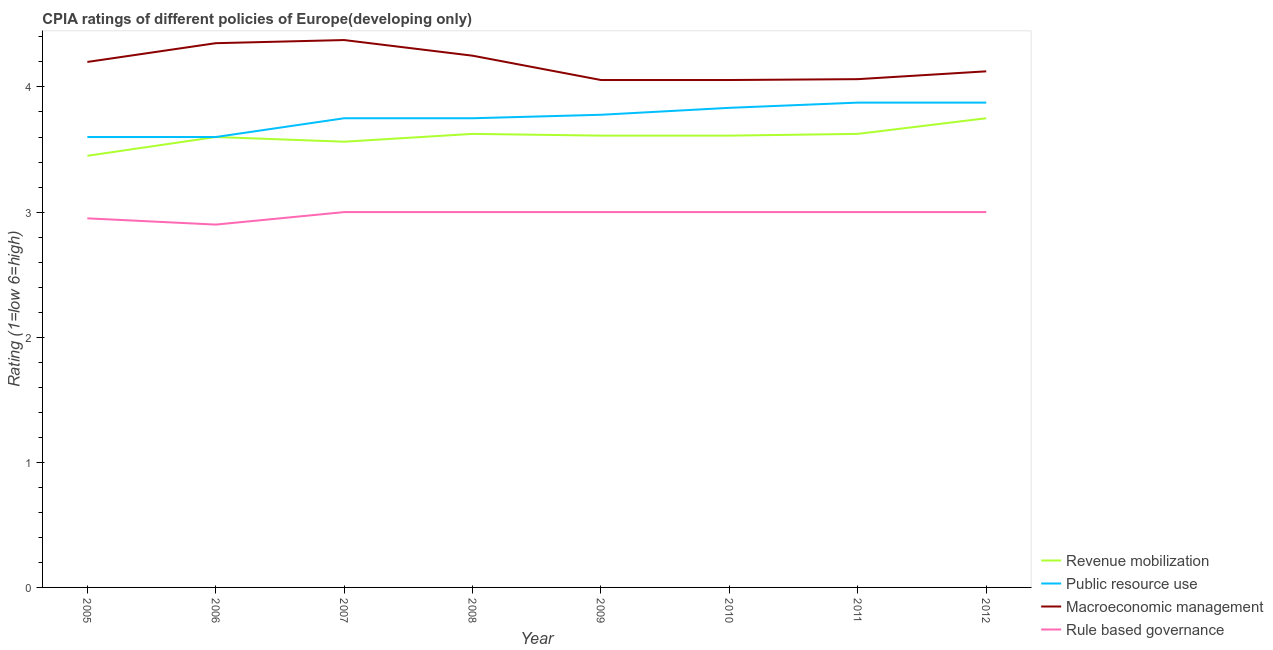Does the line corresponding to cpia rating of macroeconomic management intersect with the line corresponding to cpia rating of public resource use?
Provide a short and direct response. No. What is the cpia rating of revenue mobilization in 2011?
Keep it short and to the point. 3.62. Across all years, what is the maximum cpia rating of revenue mobilization?
Your response must be concise. 3.75. In which year was the cpia rating of rule based governance minimum?
Keep it short and to the point. 2006. What is the total cpia rating of macroeconomic management in the graph?
Keep it short and to the point. 33.47. What is the difference between the cpia rating of revenue mobilization in 2006 and that in 2008?
Your answer should be compact. -0.02. What is the difference between the cpia rating of rule based governance in 2009 and the cpia rating of revenue mobilization in 2007?
Your answer should be compact. -0.56. What is the average cpia rating of macroeconomic management per year?
Ensure brevity in your answer.  4.18. What is the ratio of the cpia rating of revenue mobilization in 2006 to that in 2009?
Make the answer very short. 1. Is the cpia rating of revenue mobilization in 2010 less than that in 2012?
Make the answer very short. Yes. What is the difference between the highest and the second highest cpia rating of rule based governance?
Your answer should be compact. 0. What is the difference between the highest and the lowest cpia rating of rule based governance?
Provide a succinct answer. 0.1. In how many years, is the cpia rating of rule based governance greater than the average cpia rating of rule based governance taken over all years?
Offer a terse response. 6. Is the sum of the cpia rating of rule based governance in 2009 and 2012 greater than the maximum cpia rating of public resource use across all years?
Give a very brief answer. Yes. Is it the case that in every year, the sum of the cpia rating of rule based governance and cpia rating of revenue mobilization is greater than the sum of cpia rating of macroeconomic management and cpia rating of public resource use?
Offer a terse response. No. Is it the case that in every year, the sum of the cpia rating of revenue mobilization and cpia rating of public resource use is greater than the cpia rating of macroeconomic management?
Make the answer very short. Yes. Is the cpia rating of public resource use strictly greater than the cpia rating of rule based governance over the years?
Provide a succinct answer. Yes. How many lines are there?
Make the answer very short. 4. What is the difference between two consecutive major ticks on the Y-axis?
Make the answer very short. 1. Are the values on the major ticks of Y-axis written in scientific E-notation?
Provide a succinct answer. No. Does the graph contain any zero values?
Your answer should be very brief. No. Does the graph contain grids?
Your answer should be very brief. No. Where does the legend appear in the graph?
Offer a very short reply. Bottom right. How are the legend labels stacked?
Keep it short and to the point. Vertical. What is the title of the graph?
Provide a short and direct response. CPIA ratings of different policies of Europe(developing only). Does "Methodology assessment" appear as one of the legend labels in the graph?
Your response must be concise. No. What is the label or title of the X-axis?
Provide a succinct answer. Year. What is the label or title of the Y-axis?
Provide a succinct answer. Rating (1=low 6=high). What is the Rating (1=low 6=high) in Revenue mobilization in 2005?
Provide a succinct answer. 3.45. What is the Rating (1=low 6=high) of Public resource use in 2005?
Provide a short and direct response. 3.6. What is the Rating (1=low 6=high) in Rule based governance in 2005?
Offer a terse response. 2.95. What is the Rating (1=low 6=high) in Revenue mobilization in 2006?
Your answer should be very brief. 3.6. What is the Rating (1=low 6=high) of Macroeconomic management in 2006?
Make the answer very short. 4.35. What is the Rating (1=low 6=high) in Revenue mobilization in 2007?
Your answer should be compact. 3.56. What is the Rating (1=low 6=high) in Public resource use in 2007?
Keep it short and to the point. 3.75. What is the Rating (1=low 6=high) of Macroeconomic management in 2007?
Give a very brief answer. 4.38. What is the Rating (1=low 6=high) in Revenue mobilization in 2008?
Make the answer very short. 3.62. What is the Rating (1=low 6=high) in Public resource use in 2008?
Give a very brief answer. 3.75. What is the Rating (1=low 6=high) in Macroeconomic management in 2008?
Your response must be concise. 4.25. What is the Rating (1=low 6=high) in Revenue mobilization in 2009?
Your response must be concise. 3.61. What is the Rating (1=low 6=high) of Public resource use in 2009?
Ensure brevity in your answer.  3.78. What is the Rating (1=low 6=high) of Macroeconomic management in 2009?
Keep it short and to the point. 4.06. What is the Rating (1=low 6=high) of Revenue mobilization in 2010?
Offer a terse response. 3.61. What is the Rating (1=low 6=high) in Public resource use in 2010?
Provide a succinct answer. 3.83. What is the Rating (1=low 6=high) in Macroeconomic management in 2010?
Your answer should be compact. 4.06. What is the Rating (1=low 6=high) of Rule based governance in 2010?
Ensure brevity in your answer.  3. What is the Rating (1=low 6=high) in Revenue mobilization in 2011?
Your answer should be compact. 3.62. What is the Rating (1=low 6=high) in Public resource use in 2011?
Give a very brief answer. 3.88. What is the Rating (1=low 6=high) of Macroeconomic management in 2011?
Ensure brevity in your answer.  4.06. What is the Rating (1=low 6=high) in Rule based governance in 2011?
Your response must be concise. 3. What is the Rating (1=low 6=high) in Revenue mobilization in 2012?
Your answer should be compact. 3.75. What is the Rating (1=low 6=high) in Public resource use in 2012?
Ensure brevity in your answer.  3.88. What is the Rating (1=low 6=high) of Macroeconomic management in 2012?
Provide a short and direct response. 4.12. What is the Rating (1=low 6=high) of Rule based governance in 2012?
Provide a succinct answer. 3. Across all years, what is the maximum Rating (1=low 6=high) of Revenue mobilization?
Offer a terse response. 3.75. Across all years, what is the maximum Rating (1=low 6=high) in Public resource use?
Offer a terse response. 3.88. Across all years, what is the maximum Rating (1=low 6=high) in Macroeconomic management?
Offer a very short reply. 4.38. Across all years, what is the minimum Rating (1=low 6=high) of Revenue mobilization?
Ensure brevity in your answer.  3.45. Across all years, what is the minimum Rating (1=low 6=high) in Macroeconomic management?
Your answer should be compact. 4.06. Across all years, what is the minimum Rating (1=low 6=high) in Rule based governance?
Your response must be concise. 2.9. What is the total Rating (1=low 6=high) in Revenue mobilization in the graph?
Provide a short and direct response. 28.83. What is the total Rating (1=low 6=high) in Public resource use in the graph?
Offer a very short reply. 30.06. What is the total Rating (1=low 6=high) in Macroeconomic management in the graph?
Your response must be concise. 33.47. What is the total Rating (1=low 6=high) in Rule based governance in the graph?
Provide a succinct answer. 23.85. What is the difference between the Rating (1=low 6=high) of Public resource use in 2005 and that in 2006?
Give a very brief answer. 0. What is the difference between the Rating (1=low 6=high) in Macroeconomic management in 2005 and that in 2006?
Offer a very short reply. -0.15. What is the difference between the Rating (1=low 6=high) in Rule based governance in 2005 and that in 2006?
Keep it short and to the point. 0.05. What is the difference between the Rating (1=low 6=high) in Revenue mobilization in 2005 and that in 2007?
Make the answer very short. -0.11. What is the difference between the Rating (1=low 6=high) in Macroeconomic management in 2005 and that in 2007?
Provide a succinct answer. -0.17. What is the difference between the Rating (1=low 6=high) in Revenue mobilization in 2005 and that in 2008?
Keep it short and to the point. -0.17. What is the difference between the Rating (1=low 6=high) of Rule based governance in 2005 and that in 2008?
Make the answer very short. -0.05. What is the difference between the Rating (1=low 6=high) of Revenue mobilization in 2005 and that in 2009?
Provide a succinct answer. -0.16. What is the difference between the Rating (1=low 6=high) in Public resource use in 2005 and that in 2009?
Your answer should be compact. -0.18. What is the difference between the Rating (1=low 6=high) of Macroeconomic management in 2005 and that in 2009?
Provide a succinct answer. 0.14. What is the difference between the Rating (1=low 6=high) in Rule based governance in 2005 and that in 2009?
Make the answer very short. -0.05. What is the difference between the Rating (1=low 6=high) of Revenue mobilization in 2005 and that in 2010?
Ensure brevity in your answer.  -0.16. What is the difference between the Rating (1=low 6=high) in Public resource use in 2005 and that in 2010?
Your response must be concise. -0.23. What is the difference between the Rating (1=low 6=high) in Macroeconomic management in 2005 and that in 2010?
Your answer should be very brief. 0.14. What is the difference between the Rating (1=low 6=high) in Rule based governance in 2005 and that in 2010?
Provide a succinct answer. -0.05. What is the difference between the Rating (1=low 6=high) in Revenue mobilization in 2005 and that in 2011?
Provide a succinct answer. -0.17. What is the difference between the Rating (1=low 6=high) of Public resource use in 2005 and that in 2011?
Your answer should be compact. -0.28. What is the difference between the Rating (1=low 6=high) of Macroeconomic management in 2005 and that in 2011?
Provide a succinct answer. 0.14. What is the difference between the Rating (1=low 6=high) in Public resource use in 2005 and that in 2012?
Provide a succinct answer. -0.28. What is the difference between the Rating (1=low 6=high) of Macroeconomic management in 2005 and that in 2012?
Give a very brief answer. 0.07. What is the difference between the Rating (1=low 6=high) of Rule based governance in 2005 and that in 2012?
Keep it short and to the point. -0.05. What is the difference between the Rating (1=low 6=high) in Revenue mobilization in 2006 and that in 2007?
Provide a succinct answer. 0.04. What is the difference between the Rating (1=low 6=high) in Public resource use in 2006 and that in 2007?
Your answer should be very brief. -0.15. What is the difference between the Rating (1=low 6=high) in Macroeconomic management in 2006 and that in 2007?
Ensure brevity in your answer.  -0.03. What is the difference between the Rating (1=low 6=high) in Rule based governance in 2006 and that in 2007?
Make the answer very short. -0.1. What is the difference between the Rating (1=low 6=high) of Revenue mobilization in 2006 and that in 2008?
Provide a succinct answer. -0.03. What is the difference between the Rating (1=low 6=high) of Macroeconomic management in 2006 and that in 2008?
Your answer should be very brief. 0.1. What is the difference between the Rating (1=low 6=high) in Rule based governance in 2006 and that in 2008?
Offer a terse response. -0.1. What is the difference between the Rating (1=low 6=high) in Revenue mobilization in 2006 and that in 2009?
Offer a very short reply. -0.01. What is the difference between the Rating (1=low 6=high) of Public resource use in 2006 and that in 2009?
Offer a very short reply. -0.18. What is the difference between the Rating (1=low 6=high) of Macroeconomic management in 2006 and that in 2009?
Make the answer very short. 0.29. What is the difference between the Rating (1=low 6=high) in Rule based governance in 2006 and that in 2009?
Provide a succinct answer. -0.1. What is the difference between the Rating (1=low 6=high) in Revenue mobilization in 2006 and that in 2010?
Provide a short and direct response. -0.01. What is the difference between the Rating (1=low 6=high) of Public resource use in 2006 and that in 2010?
Offer a very short reply. -0.23. What is the difference between the Rating (1=low 6=high) of Macroeconomic management in 2006 and that in 2010?
Offer a very short reply. 0.29. What is the difference between the Rating (1=low 6=high) of Rule based governance in 2006 and that in 2010?
Your answer should be compact. -0.1. What is the difference between the Rating (1=low 6=high) of Revenue mobilization in 2006 and that in 2011?
Offer a very short reply. -0.03. What is the difference between the Rating (1=low 6=high) of Public resource use in 2006 and that in 2011?
Offer a terse response. -0.28. What is the difference between the Rating (1=low 6=high) in Macroeconomic management in 2006 and that in 2011?
Provide a short and direct response. 0.29. What is the difference between the Rating (1=low 6=high) in Revenue mobilization in 2006 and that in 2012?
Provide a succinct answer. -0.15. What is the difference between the Rating (1=low 6=high) in Public resource use in 2006 and that in 2012?
Give a very brief answer. -0.28. What is the difference between the Rating (1=low 6=high) of Macroeconomic management in 2006 and that in 2012?
Ensure brevity in your answer.  0.23. What is the difference between the Rating (1=low 6=high) of Revenue mobilization in 2007 and that in 2008?
Keep it short and to the point. -0.06. What is the difference between the Rating (1=low 6=high) of Rule based governance in 2007 and that in 2008?
Offer a very short reply. 0. What is the difference between the Rating (1=low 6=high) in Revenue mobilization in 2007 and that in 2009?
Make the answer very short. -0.05. What is the difference between the Rating (1=low 6=high) of Public resource use in 2007 and that in 2009?
Keep it short and to the point. -0.03. What is the difference between the Rating (1=low 6=high) in Macroeconomic management in 2007 and that in 2009?
Make the answer very short. 0.32. What is the difference between the Rating (1=low 6=high) of Rule based governance in 2007 and that in 2009?
Provide a short and direct response. 0. What is the difference between the Rating (1=low 6=high) of Revenue mobilization in 2007 and that in 2010?
Your answer should be compact. -0.05. What is the difference between the Rating (1=low 6=high) of Public resource use in 2007 and that in 2010?
Your response must be concise. -0.08. What is the difference between the Rating (1=low 6=high) in Macroeconomic management in 2007 and that in 2010?
Your answer should be compact. 0.32. What is the difference between the Rating (1=low 6=high) of Rule based governance in 2007 and that in 2010?
Ensure brevity in your answer.  0. What is the difference between the Rating (1=low 6=high) in Revenue mobilization in 2007 and that in 2011?
Provide a succinct answer. -0.06. What is the difference between the Rating (1=low 6=high) in Public resource use in 2007 and that in 2011?
Your response must be concise. -0.12. What is the difference between the Rating (1=low 6=high) of Macroeconomic management in 2007 and that in 2011?
Your response must be concise. 0.31. What is the difference between the Rating (1=low 6=high) in Rule based governance in 2007 and that in 2011?
Offer a very short reply. 0. What is the difference between the Rating (1=low 6=high) of Revenue mobilization in 2007 and that in 2012?
Provide a succinct answer. -0.19. What is the difference between the Rating (1=low 6=high) of Public resource use in 2007 and that in 2012?
Provide a succinct answer. -0.12. What is the difference between the Rating (1=low 6=high) in Rule based governance in 2007 and that in 2012?
Offer a terse response. 0. What is the difference between the Rating (1=low 6=high) in Revenue mobilization in 2008 and that in 2009?
Offer a very short reply. 0.01. What is the difference between the Rating (1=low 6=high) in Public resource use in 2008 and that in 2009?
Your answer should be very brief. -0.03. What is the difference between the Rating (1=low 6=high) of Macroeconomic management in 2008 and that in 2009?
Offer a terse response. 0.19. What is the difference between the Rating (1=low 6=high) of Revenue mobilization in 2008 and that in 2010?
Your answer should be compact. 0.01. What is the difference between the Rating (1=low 6=high) of Public resource use in 2008 and that in 2010?
Your response must be concise. -0.08. What is the difference between the Rating (1=low 6=high) of Macroeconomic management in 2008 and that in 2010?
Ensure brevity in your answer.  0.19. What is the difference between the Rating (1=low 6=high) in Public resource use in 2008 and that in 2011?
Offer a terse response. -0.12. What is the difference between the Rating (1=low 6=high) of Macroeconomic management in 2008 and that in 2011?
Give a very brief answer. 0.19. What is the difference between the Rating (1=low 6=high) in Rule based governance in 2008 and that in 2011?
Offer a very short reply. 0. What is the difference between the Rating (1=low 6=high) of Revenue mobilization in 2008 and that in 2012?
Give a very brief answer. -0.12. What is the difference between the Rating (1=low 6=high) of Public resource use in 2008 and that in 2012?
Offer a terse response. -0.12. What is the difference between the Rating (1=low 6=high) of Rule based governance in 2008 and that in 2012?
Provide a short and direct response. 0. What is the difference between the Rating (1=low 6=high) of Public resource use in 2009 and that in 2010?
Keep it short and to the point. -0.06. What is the difference between the Rating (1=low 6=high) in Rule based governance in 2009 and that in 2010?
Your response must be concise. 0. What is the difference between the Rating (1=low 6=high) of Revenue mobilization in 2009 and that in 2011?
Keep it short and to the point. -0.01. What is the difference between the Rating (1=low 6=high) in Public resource use in 2009 and that in 2011?
Ensure brevity in your answer.  -0.1. What is the difference between the Rating (1=low 6=high) of Macroeconomic management in 2009 and that in 2011?
Make the answer very short. -0.01. What is the difference between the Rating (1=low 6=high) of Rule based governance in 2009 and that in 2011?
Make the answer very short. 0. What is the difference between the Rating (1=low 6=high) of Revenue mobilization in 2009 and that in 2012?
Your response must be concise. -0.14. What is the difference between the Rating (1=low 6=high) of Public resource use in 2009 and that in 2012?
Your answer should be compact. -0.1. What is the difference between the Rating (1=low 6=high) in Macroeconomic management in 2009 and that in 2012?
Your response must be concise. -0.07. What is the difference between the Rating (1=low 6=high) in Revenue mobilization in 2010 and that in 2011?
Your answer should be compact. -0.01. What is the difference between the Rating (1=low 6=high) of Public resource use in 2010 and that in 2011?
Ensure brevity in your answer.  -0.04. What is the difference between the Rating (1=low 6=high) in Macroeconomic management in 2010 and that in 2011?
Offer a terse response. -0.01. What is the difference between the Rating (1=low 6=high) of Rule based governance in 2010 and that in 2011?
Give a very brief answer. 0. What is the difference between the Rating (1=low 6=high) of Revenue mobilization in 2010 and that in 2012?
Keep it short and to the point. -0.14. What is the difference between the Rating (1=low 6=high) of Public resource use in 2010 and that in 2012?
Give a very brief answer. -0.04. What is the difference between the Rating (1=low 6=high) of Macroeconomic management in 2010 and that in 2012?
Your response must be concise. -0.07. What is the difference between the Rating (1=low 6=high) in Rule based governance in 2010 and that in 2012?
Give a very brief answer. 0. What is the difference between the Rating (1=low 6=high) of Revenue mobilization in 2011 and that in 2012?
Provide a succinct answer. -0.12. What is the difference between the Rating (1=low 6=high) of Public resource use in 2011 and that in 2012?
Your answer should be very brief. 0. What is the difference between the Rating (1=low 6=high) in Macroeconomic management in 2011 and that in 2012?
Make the answer very short. -0.06. What is the difference between the Rating (1=low 6=high) in Revenue mobilization in 2005 and the Rating (1=low 6=high) in Public resource use in 2006?
Make the answer very short. -0.15. What is the difference between the Rating (1=low 6=high) of Revenue mobilization in 2005 and the Rating (1=low 6=high) of Macroeconomic management in 2006?
Offer a very short reply. -0.9. What is the difference between the Rating (1=low 6=high) of Revenue mobilization in 2005 and the Rating (1=low 6=high) of Rule based governance in 2006?
Offer a very short reply. 0.55. What is the difference between the Rating (1=low 6=high) in Public resource use in 2005 and the Rating (1=low 6=high) in Macroeconomic management in 2006?
Your answer should be compact. -0.75. What is the difference between the Rating (1=low 6=high) of Revenue mobilization in 2005 and the Rating (1=low 6=high) of Public resource use in 2007?
Provide a short and direct response. -0.3. What is the difference between the Rating (1=low 6=high) in Revenue mobilization in 2005 and the Rating (1=low 6=high) in Macroeconomic management in 2007?
Give a very brief answer. -0.93. What is the difference between the Rating (1=low 6=high) of Revenue mobilization in 2005 and the Rating (1=low 6=high) of Rule based governance in 2007?
Ensure brevity in your answer.  0.45. What is the difference between the Rating (1=low 6=high) of Public resource use in 2005 and the Rating (1=low 6=high) of Macroeconomic management in 2007?
Provide a short and direct response. -0.78. What is the difference between the Rating (1=low 6=high) in Public resource use in 2005 and the Rating (1=low 6=high) in Rule based governance in 2007?
Provide a succinct answer. 0.6. What is the difference between the Rating (1=low 6=high) of Revenue mobilization in 2005 and the Rating (1=low 6=high) of Rule based governance in 2008?
Provide a succinct answer. 0.45. What is the difference between the Rating (1=low 6=high) in Public resource use in 2005 and the Rating (1=low 6=high) in Macroeconomic management in 2008?
Offer a very short reply. -0.65. What is the difference between the Rating (1=low 6=high) of Public resource use in 2005 and the Rating (1=low 6=high) of Rule based governance in 2008?
Offer a terse response. 0.6. What is the difference between the Rating (1=low 6=high) of Macroeconomic management in 2005 and the Rating (1=low 6=high) of Rule based governance in 2008?
Make the answer very short. 1.2. What is the difference between the Rating (1=low 6=high) of Revenue mobilization in 2005 and the Rating (1=low 6=high) of Public resource use in 2009?
Your answer should be very brief. -0.33. What is the difference between the Rating (1=low 6=high) in Revenue mobilization in 2005 and the Rating (1=low 6=high) in Macroeconomic management in 2009?
Ensure brevity in your answer.  -0.61. What is the difference between the Rating (1=low 6=high) of Revenue mobilization in 2005 and the Rating (1=low 6=high) of Rule based governance in 2009?
Provide a succinct answer. 0.45. What is the difference between the Rating (1=low 6=high) in Public resource use in 2005 and the Rating (1=low 6=high) in Macroeconomic management in 2009?
Your answer should be compact. -0.46. What is the difference between the Rating (1=low 6=high) in Public resource use in 2005 and the Rating (1=low 6=high) in Rule based governance in 2009?
Your answer should be compact. 0.6. What is the difference between the Rating (1=low 6=high) of Macroeconomic management in 2005 and the Rating (1=low 6=high) of Rule based governance in 2009?
Your response must be concise. 1.2. What is the difference between the Rating (1=low 6=high) in Revenue mobilization in 2005 and the Rating (1=low 6=high) in Public resource use in 2010?
Your answer should be compact. -0.38. What is the difference between the Rating (1=low 6=high) in Revenue mobilization in 2005 and the Rating (1=low 6=high) in Macroeconomic management in 2010?
Provide a succinct answer. -0.61. What is the difference between the Rating (1=low 6=high) in Revenue mobilization in 2005 and the Rating (1=low 6=high) in Rule based governance in 2010?
Provide a short and direct response. 0.45. What is the difference between the Rating (1=low 6=high) in Public resource use in 2005 and the Rating (1=low 6=high) in Macroeconomic management in 2010?
Offer a terse response. -0.46. What is the difference between the Rating (1=low 6=high) in Public resource use in 2005 and the Rating (1=low 6=high) in Rule based governance in 2010?
Give a very brief answer. 0.6. What is the difference between the Rating (1=low 6=high) in Revenue mobilization in 2005 and the Rating (1=low 6=high) in Public resource use in 2011?
Your answer should be compact. -0.42. What is the difference between the Rating (1=low 6=high) in Revenue mobilization in 2005 and the Rating (1=low 6=high) in Macroeconomic management in 2011?
Give a very brief answer. -0.61. What is the difference between the Rating (1=low 6=high) in Revenue mobilization in 2005 and the Rating (1=low 6=high) in Rule based governance in 2011?
Your answer should be compact. 0.45. What is the difference between the Rating (1=low 6=high) of Public resource use in 2005 and the Rating (1=low 6=high) of Macroeconomic management in 2011?
Your answer should be very brief. -0.46. What is the difference between the Rating (1=low 6=high) of Public resource use in 2005 and the Rating (1=low 6=high) of Rule based governance in 2011?
Keep it short and to the point. 0.6. What is the difference between the Rating (1=low 6=high) in Macroeconomic management in 2005 and the Rating (1=low 6=high) in Rule based governance in 2011?
Offer a very short reply. 1.2. What is the difference between the Rating (1=low 6=high) in Revenue mobilization in 2005 and the Rating (1=low 6=high) in Public resource use in 2012?
Provide a short and direct response. -0.42. What is the difference between the Rating (1=low 6=high) of Revenue mobilization in 2005 and the Rating (1=low 6=high) of Macroeconomic management in 2012?
Ensure brevity in your answer.  -0.68. What is the difference between the Rating (1=low 6=high) in Revenue mobilization in 2005 and the Rating (1=low 6=high) in Rule based governance in 2012?
Offer a terse response. 0.45. What is the difference between the Rating (1=low 6=high) in Public resource use in 2005 and the Rating (1=low 6=high) in Macroeconomic management in 2012?
Your response must be concise. -0.53. What is the difference between the Rating (1=low 6=high) of Macroeconomic management in 2005 and the Rating (1=low 6=high) of Rule based governance in 2012?
Ensure brevity in your answer.  1.2. What is the difference between the Rating (1=low 6=high) of Revenue mobilization in 2006 and the Rating (1=low 6=high) of Public resource use in 2007?
Keep it short and to the point. -0.15. What is the difference between the Rating (1=low 6=high) of Revenue mobilization in 2006 and the Rating (1=low 6=high) of Macroeconomic management in 2007?
Provide a succinct answer. -0.78. What is the difference between the Rating (1=low 6=high) in Revenue mobilization in 2006 and the Rating (1=low 6=high) in Rule based governance in 2007?
Give a very brief answer. 0.6. What is the difference between the Rating (1=low 6=high) in Public resource use in 2006 and the Rating (1=low 6=high) in Macroeconomic management in 2007?
Ensure brevity in your answer.  -0.78. What is the difference between the Rating (1=low 6=high) of Public resource use in 2006 and the Rating (1=low 6=high) of Rule based governance in 2007?
Provide a short and direct response. 0.6. What is the difference between the Rating (1=low 6=high) in Macroeconomic management in 2006 and the Rating (1=low 6=high) in Rule based governance in 2007?
Offer a terse response. 1.35. What is the difference between the Rating (1=low 6=high) of Revenue mobilization in 2006 and the Rating (1=low 6=high) of Public resource use in 2008?
Give a very brief answer. -0.15. What is the difference between the Rating (1=low 6=high) of Revenue mobilization in 2006 and the Rating (1=low 6=high) of Macroeconomic management in 2008?
Give a very brief answer. -0.65. What is the difference between the Rating (1=low 6=high) in Public resource use in 2006 and the Rating (1=low 6=high) in Macroeconomic management in 2008?
Offer a very short reply. -0.65. What is the difference between the Rating (1=low 6=high) of Public resource use in 2006 and the Rating (1=low 6=high) of Rule based governance in 2008?
Provide a succinct answer. 0.6. What is the difference between the Rating (1=low 6=high) in Macroeconomic management in 2006 and the Rating (1=low 6=high) in Rule based governance in 2008?
Your answer should be compact. 1.35. What is the difference between the Rating (1=low 6=high) of Revenue mobilization in 2006 and the Rating (1=low 6=high) of Public resource use in 2009?
Give a very brief answer. -0.18. What is the difference between the Rating (1=low 6=high) in Revenue mobilization in 2006 and the Rating (1=low 6=high) in Macroeconomic management in 2009?
Offer a terse response. -0.46. What is the difference between the Rating (1=low 6=high) of Revenue mobilization in 2006 and the Rating (1=low 6=high) of Rule based governance in 2009?
Offer a very short reply. 0.6. What is the difference between the Rating (1=low 6=high) in Public resource use in 2006 and the Rating (1=low 6=high) in Macroeconomic management in 2009?
Offer a terse response. -0.46. What is the difference between the Rating (1=low 6=high) in Public resource use in 2006 and the Rating (1=low 6=high) in Rule based governance in 2009?
Your answer should be compact. 0.6. What is the difference between the Rating (1=low 6=high) in Macroeconomic management in 2006 and the Rating (1=low 6=high) in Rule based governance in 2009?
Provide a succinct answer. 1.35. What is the difference between the Rating (1=low 6=high) in Revenue mobilization in 2006 and the Rating (1=low 6=high) in Public resource use in 2010?
Provide a succinct answer. -0.23. What is the difference between the Rating (1=low 6=high) in Revenue mobilization in 2006 and the Rating (1=low 6=high) in Macroeconomic management in 2010?
Your answer should be compact. -0.46. What is the difference between the Rating (1=low 6=high) in Public resource use in 2006 and the Rating (1=low 6=high) in Macroeconomic management in 2010?
Offer a terse response. -0.46. What is the difference between the Rating (1=low 6=high) in Macroeconomic management in 2006 and the Rating (1=low 6=high) in Rule based governance in 2010?
Offer a very short reply. 1.35. What is the difference between the Rating (1=low 6=high) in Revenue mobilization in 2006 and the Rating (1=low 6=high) in Public resource use in 2011?
Provide a short and direct response. -0.28. What is the difference between the Rating (1=low 6=high) of Revenue mobilization in 2006 and the Rating (1=low 6=high) of Macroeconomic management in 2011?
Offer a very short reply. -0.46. What is the difference between the Rating (1=low 6=high) of Public resource use in 2006 and the Rating (1=low 6=high) of Macroeconomic management in 2011?
Make the answer very short. -0.46. What is the difference between the Rating (1=low 6=high) of Macroeconomic management in 2006 and the Rating (1=low 6=high) of Rule based governance in 2011?
Offer a very short reply. 1.35. What is the difference between the Rating (1=low 6=high) in Revenue mobilization in 2006 and the Rating (1=low 6=high) in Public resource use in 2012?
Ensure brevity in your answer.  -0.28. What is the difference between the Rating (1=low 6=high) of Revenue mobilization in 2006 and the Rating (1=low 6=high) of Macroeconomic management in 2012?
Your answer should be compact. -0.53. What is the difference between the Rating (1=low 6=high) of Revenue mobilization in 2006 and the Rating (1=low 6=high) of Rule based governance in 2012?
Your response must be concise. 0.6. What is the difference between the Rating (1=low 6=high) in Public resource use in 2006 and the Rating (1=low 6=high) in Macroeconomic management in 2012?
Offer a very short reply. -0.53. What is the difference between the Rating (1=low 6=high) in Public resource use in 2006 and the Rating (1=low 6=high) in Rule based governance in 2012?
Make the answer very short. 0.6. What is the difference between the Rating (1=low 6=high) of Macroeconomic management in 2006 and the Rating (1=low 6=high) of Rule based governance in 2012?
Keep it short and to the point. 1.35. What is the difference between the Rating (1=low 6=high) of Revenue mobilization in 2007 and the Rating (1=low 6=high) of Public resource use in 2008?
Offer a very short reply. -0.19. What is the difference between the Rating (1=low 6=high) of Revenue mobilization in 2007 and the Rating (1=low 6=high) of Macroeconomic management in 2008?
Make the answer very short. -0.69. What is the difference between the Rating (1=low 6=high) in Revenue mobilization in 2007 and the Rating (1=low 6=high) in Rule based governance in 2008?
Make the answer very short. 0.56. What is the difference between the Rating (1=low 6=high) of Public resource use in 2007 and the Rating (1=low 6=high) of Macroeconomic management in 2008?
Your response must be concise. -0.5. What is the difference between the Rating (1=low 6=high) of Macroeconomic management in 2007 and the Rating (1=low 6=high) of Rule based governance in 2008?
Keep it short and to the point. 1.38. What is the difference between the Rating (1=low 6=high) in Revenue mobilization in 2007 and the Rating (1=low 6=high) in Public resource use in 2009?
Offer a very short reply. -0.22. What is the difference between the Rating (1=low 6=high) in Revenue mobilization in 2007 and the Rating (1=low 6=high) in Macroeconomic management in 2009?
Your answer should be compact. -0.49. What is the difference between the Rating (1=low 6=high) of Revenue mobilization in 2007 and the Rating (1=low 6=high) of Rule based governance in 2009?
Offer a very short reply. 0.56. What is the difference between the Rating (1=low 6=high) of Public resource use in 2007 and the Rating (1=low 6=high) of Macroeconomic management in 2009?
Your answer should be compact. -0.31. What is the difference between the Rating (1=low 6=high) of Public resource use in 2007 and the Rating (1=low 6=high) of Rule based governance in 2009?
Make the answer very short. 0.75. What is the difference between the Rating (1=low 6=high) in Macroeconomic management in 2007 and the Rating (1=low 6=high) in Rule based governance in 2009?
Your response must be concise. 1.38. What is the difference between the Rating (1=low 6=high) in Revenue mobilization in 2007 and the Rating (1=low 6=high) in Public resource use in 2010?
Make the answer very short. -0.27. What is the difference between the Rating (1=low 6=high) in Revenue mobilization in 2007 and the Rating (1=low 6=high) in Macroeconomic management in 2010?
Keep it short and to the point. -0.49. What is the difference between the Rating (1=low 6=high) in Revenue mobilization in 2007 and the Rating (1=low 6=high) in Rule based governance in 2010?
Provide a short and direct response. 0.56. What is the difference between the Rating (1=low 6=high) of Public resource use in 2007 and the Rating (1=low 6=high) of Macroeconomic management in 2010?
Ensure brevity in your answer.  -0.31. What is the difference between the Rating (1=low 6=high) in Public resource use in 2007 and the Rating (1=low 6=high) in Rule based governance in 2010?
Your answer should be compact. 0.75. What is the difference between the Rating (1=low 6=high) of Macroeconomic management in 2007 and the Rating (1=low 6=high) of Rule based governance in 2010?
Your answer should be very brief. 1.38. What is the difference between the Rating (1=low 6=high) of Revenue mobilization in 2007 and the Rating (1=low 6=high) of Public resource use in 2011?
Ensure brevity in your answer.  -0.31. What is the difference between the Rating (1=low 6=high) of Revenue mobilization in 2007 and the Rating (1=low 6=high) of Rule based governance in 2011?
Ensure brevity in your answer.  0.56. What is the difference between the Rating (1=low 6=high) of Public resource use in 2007 and the Rating (1=low 6=high) of Macroeconomic management in 2011?
Keep it short and to the point. -0.31. What is the difference between the Rating (1=low 6=high) in Macroeconomic management in 2007 and the Rating (1=low 6=high) in Rule based governance in 2011?
Offer a very short reply. 1.38. What is the difference between the Rating (1=low 6=high) in Revenue mobilization in 2007 and the Rating (1=low 6=high) in Public resource use in 2012?
Offer a very short reply. -0.31. What is the difference between the Rating (1=low 6=high) of Revenue mobilization in 2007 and the Rating (1=low 6=high) of Macroeconomic management in 2012?
Keep it short and to the point. -0.56. What is the difference between the Rating (1=low 6=high) of Revenue mobilization in 2007 and the Rating (1=low 6=high) of Rule based governance in 2012?
Provide a short and direct response. 0.56. What is the difference between the Rating (1=low 6=high) in Public resource use in 2007 and the Rating (1=low 6=high) in Macroeconomic management in 2012?
Keep it short and to the point. -0.38. What is the difference between the Rating (1=low 6=high) in Public resource use in 2007 and the Rating (1=low 6=high) in Rule based governance in 2012?
Provide a succinct answer. 0.75. What is the difference between the Rating (1=low 6=high) in Macroeconomic management in 2007 and the Rating (1=low 6=high) in Rule based governance in 2012?
Your response must be concise. 1.38. What is the difference between the Rating (1=low 6=high) in Revenue mobilization in 2008 and the Rating (1=low 6=high) in Public resource use in 2009?
Your response must be concise. -0.15. What is the difference between the Rating (1=low 6=high) of Revenue mobilization in 2008 and the Rating (1=low 6=high) of Macroeconomic management in 2009?
Offer a very short reply. -0.43. What is the difference between the Rating (1=low 6=high) of Revenue mobilization in 2008 and the Rating (1=low 6=high) of Rule based governance in 2009?
Your answer should be compact. 0.62. What is the difference between the Rating (1=low 6=high) of Public resource use in 2008 and the Rating (1=low 6=high) of Macroeconomic management in 2009?
Ensure brevity in your answer.  -0.31. What is the difference between the Rating (1=low 6=high) in Macroeconomic management in 2008 and the Rating (1=low 6=high) in Rule based governance in 2009?
Offer a terse response. 1.25. What is the difference between the Rating (1=low 6=high) of Revenue mobilization in 2008 and the Rating (1=low 6=high) of Public resource use in 2010?
Your answer should be compact. -0.21. What is the difference between the Rating (1=low 6=high) in Revenue mobilization in 2008 and the Rating (1=low 6=high) in Macroeconomic management in 2010?
Give a very brief answer. -0.43. What is the difference between the Rating (1=low 6=high) of Public resource use in 2008 and the Rating (1=low 6=high) of Macroeconomic management in 2010?
Your response must be concise. -0.31. What is the difference between the Rating (1=low 6=high) of Public resource use in 2008 and the Rating (1=low 6=high) of Rule based governance in 2010?
Provide a succinct answer. 0.75. What is the difference between the Rating (1=low 6=high) of Revenue mobilization in 2008 and the Rating (1=low 6=high) of Macroeconomic management in 2011?
Provide a short and direct response. -0.44. What is the difference between the Rating (1=low 6=high) in Public resource use in 2008 and the Rating (1=low 6=high) in Macroeconomic management in 2011?
Ensure brevity in your answer.  -0.31. What is the difference between the Rating (1=low 6=high) of Public resource use in 2008 and the Rating (1=low 6=high) of Rule based governance in 2011?
Provide a short and direct response. 0.75. What is the difference between the Rating (1=low 6=high) of Revenue mobilization in 2008 and the Rating (1=low 6=high) of Public resource use in 2012?
Ensure brevity in your answer.  -0.25. What is the difference between the Rating (1=low 6=high) in Public resource use in 2008 and the Rating (1=low 6=high) in Macroeconomic management in 2012?
Ensure brevity in your answer.  -0.38. What is the difference between the Rating (1=low 6=high) in Revenue mobilization in 2009 and the Rating (1=low 6=high) in Public resource use in 2010?
Ensure brevity in your answer.  -0.22. What is the difference between the Rating (1=low 6=high) of Revenue mobilization in 2009 and the Rating (1=low 6=high) of Macroeconomic management in 2010?
Offer a very short reply. -0.44. What is the difference between the Rating (1=low 6=high) in Revenue mobilization in 2009 and the Rating (1=low 6=high) in Rule based governance in 2010?
Provide a short and direct response. 0.61. What is the difference between the Rating (1=low 6=high) of Public resource use in 2009 and the Rating (1=low 6=high) of Macroeconomic management in 2010?
Make the answer very short. -0.28. What is the difference between the Rating (1=low 6=high) in Public resource use in 2009 and the Rating (1=low 6=high) in Rule based governance in 2010?
Provide a short and direct response. 0.78. What is the difference between the Rating (1=low 6=high) of Macroeconomic management in 2009 and the Rating (1=low 6=high) of Rule based governance in 2010?
Make the answer very short. 1.06. What is the difference between the Rating (1=low 6=high) of Revenue mobilization in 2009 and the Rating (1=low 6=high) of Public resource use in 2011?
Keep it short and to the point. -0.26. What is the difference between the Rating (1=low 6=high) in Revenue mobilization in 2009 and the Rating (1=low 6=high) in Macroeconomic management in 2011?
Your answer should be compact. -0.45. What is the difference between the Rating (1=low 6=high) of Revenue mobilization in 2009 and the Rating (1=low 6=high) of Rule based governance in 2011?
Your answer should be very brief. 0.61. What is the difference between the Rating (1=low 6=high) of Public resource use in 2009 and the Rating (1=low 6=high) of Macroeconomic management in 2011?
Provide a succinct answer. -0.28. What is the difference between the Rating (1=low 6=high) in Macroeconomic management in 2009 and the Rating (1=low 6=high) in Rule based governance in 2011?
Your answer should be compact. 1.06. What is the difference between the Rating (1=low 6=high) of Revenue mobilization in 2009 and the Rating (1=low 6=high) of Public resource use in 2012?
Give a very brief answer. -0.26. What is the difference between the Rating (1=low 6=high) in Revenue mobilization in 2009 and the Rating (1=low 6=high) in Macroeconomic management in 2012?
Your answer should be very brief. -0.51. What is the difference between the Rating (1=low 6=high) of Revenue mobilization in 2009 and the Rating (1=low 6=high) of Rule based governance in 2012?
Give a very brief answer. 0.61. What is the difference between the Rating (1=low 6=high) of Public resource use in 2009 and the Rating (1=low 6=high) of Macroeconomic management in 2012?
Provide a succinct answer. -0.35. What is the difference between the Rating (1=low 6=high) in Macroeconomic management in 2009 and the Rating (1=low 6=high) in Rule based governance in 2012?
Offer a very short reply. 1.06. What is the difference between the Rating (1=low 6=high) of Revenue mobilization in 2010 and the Rating (1=low 6=high) of Public resource use in 2011?
Ensure brevity in your answer.  -0.26. What is the difference between the Rating (1=low 6=high) in Revenue mobilization in 2010 and the Rating (1=low 6=high) in Macroeconomic management in 2011?
Provide a short and direct response. -0.45. What is the difference between the Rating (1=low 6=high) of Revenue mobilization in 2010 and the Rating (1=low 6=high) of Rule based governance in 2011?
Your answer should be very brief. 0.61. What is the difference between the Rating (1=low 6=high) of Public resource use in 2010 and the Rating (1=low 6=high) of Macroeconomic management in 2011?
Your response must be concise. -0.23. What is the difference between the Rating (1=low 6=high) of Macroeconomic management in 2010 and the Rating (1=low 6=high) of Rule based governance in 2011?
Your answer should be compact. 1.06. What is the difference between the Rating (1=low 6=high) of Revenue mobilization in 2010 and the Rating (1=low 6=high) of Public resource use in 2012?
Provide a short and direct response. -0.26. What is the difference between the Rating (1=low 6=high) of Revenue mobilization in 2010 and the Rating (1=low 6=high) of Macroeconomic management in 2012?
Your answer should be compact. -0.51. What is the difference between the Rating (1=low 6=high) of Revenue mobilization in 2010 and the Rating (1=low 6=high) of Rule based governance in 2012?
Make the answer very short. 0.61. What is the difference between the Rating (1=low 6=high) in Public resource use in 2010 and the Rating (1=low 6=high) in Macroeconomic management in 2012?
Your response must be concise. -0.29. What is the difference between the Rating (1=low 6=high) in Public resource use in 2010 and the Rating (1=low 6=high) in Rule based governance in 2012?
Give a very brief answer. 0.83. What is the difference between the Rating (1=low 6=high) of Macroeconomic management in 2010 and the Rating (1=low 6=high) of Rule based governance in 2012?
Offer a terse response. 1.06. What is the difference between the Rating (1=low 6=high) in Revenue mobilization in 2011 and the Rating (1=low 6=high) in Public resource use in 2012?
Provide a succinct answer. -0.25. What is the difference between the Rating (1=low 6=high) of Revenue mobilization in 2011 and the Rating (1=low 6=high) of Rule based governance in 2012?
Make the answer very short. 0.62. What is the average Rating (1=low 6=high) in Revenue mobilization per year?
Provide a short and direct response. 3.6. What is the average Rating (1=low 6=high) of Public resource use per year?
Keep it short and to the point. 3.76. What is the average Rating (1=low 6=high) of Macroeconomic management per year?
Your answer should be very brief. 4.18. What is the average Rating (1=low 6=high) of Rule based governance per year?
Offer a terse response. 2.98. In the year 2005, what is the difference between the Rating (1=low 6=high) of Revenue mobilization and Rating (1=low 6=high) of Public resource use?
Provide a succinct answer. -0.15. In the year 2005, what is the difference between the Rating (1=low 6=high) in Revenue mobilization and Rating (1=low 6=high) in Macroeconomic management?
Keep it short and to the point. -0.75. In the year 2005, what is the difference between the Rating (1=low 6=high) in Public resource use and Rating (1=low 6=high) in Macroeconomic management?
Provide a succinct answer. -0.6. In the year 2005, what is the difference between the Rating (1=low 6=high) in Public resource use and Rating (1=low 6=high) in Rule based governance?
Keep it short and to the point. 0.65. In the year 2006, what is the difference between the Rating (1=low 6=high) of Revenue mobilization and Rating (1=low 6=high) of Macroeconomic management?
Offer a very short reply. -0.75. In the year 2006, what is the difference between the Rating (1=low 6=high) in Revenue mobilization and Rating (1=low 6=high) in Rule based governance?
Give a very brief answer. 0.7. In the year 2006, what is the difference between the Rating (1=low 6=high) of Public resource use and Rating (1=low 6=high) of Macroeconomic management?
Offer a terse response. -0.75. In the year 2006, what is the difference between the Rating (1=low 6=high) of Macroeconomic management and Rating (1=low 6=high) of Rule based governance?
Offer a very short reply. 1.45. In the year 2007, what is the difference between the Rating (1=low 6=high) in Revenue mobilization and Rating (1=low 6=high) in Public resource use?
Your response must be concise. -0.19. In the year 2007, what is the difference between the Rating (1=low 6=high) of Revenue mobilization and Rating (1=low 6=high) of Macroeconomic management?
Make the answer very short. -0.81. In the year 2007, what is the difference between the Rating (1=low 6=high) in Revenue mobilization and Rating (1=low 6=high) in Rule based governance?
Your response must be concise. 0.56. In the year 2007, what is the difference between the Rating (1=low 6=high) in Public resource use and Rating (1=low 6=high) in Macroeconomic management?
Offer a very short reply. -0.62. In the year 2007, what is the difference between the Rating (1=low 6=high) of Public resource use and Rating (1=low 6=high) of Rule based governance?
Keep it short and to the point. 0.75. In the year 2007, what is the difference between the Rating (1=low 6=high) in Macroeconomic management and Rating (1=low 6=high) in Rule based governance?
Offer a terse response. 1.38. In the year 2008, what is the difference between the Rating (1=low 6=high) of Revenue mobilization and Rating (1=low 6=high) of Public resource use?
Provide a short and direct response. -0.12. In the year 2008, what is the difference between the Rating (1=low 6=high) of Revenue mobilization and Rating (1=low 6=high) of Macroeconomic management?
Make the answer very short. -0.62. In the year 2008, what is the difference between the Rating (1=low 6=high) in Public resource use and Rating (1=low 6=high) in Rule based governance?
Offer a terse response. 0.75. In the year 2009, what is the difference between the Rating (1=low 6=high) in Revenue mobilization and Rating (1=low 6=high) in Public resource use?
Provide a succinct answer. -0.17. In the year 2009, what is the difference between the Rating (1=low 6=high) of Revenue mobilization and Rating (1=low 6=high) of Macroeconomic management?
Provide a succinct answer. -0.44. In the year 2009, what is the difference between the Rating (1=low 6=high) of Revenue mobilization and Rating (1=low 6=high) of Rule based governance?
Offer a terse response. 0.61. In the year 2009, what is the difference between the Rating (1=low 6=high) of Public resource use and Rating (1=low 6=high) of Macroeconomic management?
Provide a succinct answer. -0.28. In the year 2009, what is the difference between the Rating (1=low 6=high) in Macroeconomic management and Rating (1=low 6=high) in Rule based governance?
Keep it short and to the point. 1.06. In the year 2010, what is the difference between the Rating (1=low 6=high) of Revenue mobilization and Rating (1=low 6=high) of Public resource use?
Make the answer very short. -0.22. In the year 2010, what is the difference between the Rating (1=low 6=high) in Revenue mobilization and Rating (1=low 6=high) in Macroeconomic management?
Ensure brevity in your answer.  -0.44. In the year 2010, what is the difference between the Rating (1=low 6=high) of Revenue mobilization and Rating (1=low 6=high) of Rule based governance?
Keep it short and to the point. 0.61. In the year 2010, what is the difference between the Rating (1=low 6=high) of Public resource use and Rating (1=low 6=high) of Macroeconomic management?
Offer a very short reply. -0.22. In the year 2010, what is the difference between the Rating (1=low 6=high) in Public resource use and Rating (1=low 6=high) in Rule based governance?
Your answer should be compact. 0.83. In the year 2010, what is the difference between the Rating (1=low 6=high) of Macroeconomic management and Rating (1=low 6=high) of Rule based governance?
Keep it short and to the point. 1.06. In the year 2011, what is the difference between the Rating (1=low 6=high) in Revenue mobilization and Rating (1=low 6=high) in Macroeconomic management?
Make the answer very short. -0.44. In the year 2011, what is the difference between the Rating (1=low 6=high) of Public resource use and Rating (1=low 6=high) of Macroeconomic management?
Make the answer very short. -0.19. In the year 2012, what is the difference between the Rating (1=low 6=high) of Revenue mobilization and Rating (1=low 6=high) of Public resource use?
Your answer should be compact. -0.12. In the year 2012, what is the difference between the Rating (1=low 6=high) in Revenue mobilization and Rating (1=low 6=high) in Macroeconomic management?
Offer a terse response. -0.38. In the year 2012, what is the difference between the Rating (1=low 6=high) of Macroeconomic management and Rating (1=low 6=high) of Rule based governance?
Your answer should be compact. 1.12. What is the ratio of the Rating (1=low 6=high) of Macroeconomic management in 2005 to that in 2006?
Offer a terse response. 0.97. What is the ratio of the Rating (1=low 6=high) in Rule based governance in 2005 to that in 2006?
Your answer should be compact. 1.02. What is the ratio of the Rating (1=low 6=high) of Revenue mobilization in 2005 to that in 2007?
Ensure brevity in your answer.  0.97. What is the ratio of the Rating (1=low 6=high) in Public resource use in 2005 to that in 2007?
Your answer should be compact. 0.96. What is the ratio of the Rating (1=low 6=high) in Macroeconomic management in 2005 to that in 2007?
Keep it short and to the point. 0.96. What is the ratio of the Rating (1=low 6=high) in Rule based governance in 2005 to that in 2007?
Make the answer very short. 0.98. What is the ratio of the Rating (1=low 6=high) in Revenue mobilization in 2005 to that in 2008?
Give a very brief answer. 0.95. What is the ratio of the Rating (1=low 6=high) of Public resource use in 2005 to that in 2008?
Offer a terse response. 0.96. What is the ratio of the Rating (1=low 6=high) of Rule based governance in 2005 to that in 2008?
Keep it short and to the point. 0.98. What is the ratio of the Rating (1=low 6=high) in Revenue mobilization in 2005 to that in 2009?
Your answer should be compact. 0.96. What is the ratio of the Rating (1=low 6=high) in Public resource use in 2005 to that in 2009?
Your response must be concise. 0.95. What is the ratio of the Rating (1=low 6=high) of Macroeconomic management in 2005 to that in 2009?
Make the answer very short. 1.04. What is the ratio of the Rating (1=low 6=high) of Rule based governance in 2005 to that in 2009?
Give a very brief answer. 0.98. What is the ratio of the Rating (1=low 6=high) in Revenue mobilization in 2005 to that in 2010?
Provide a succinct answer. 0.96. What is the ratio of the Rating (1=low 6=high) in Public resource use in 2005 to that in 2010?
Give a very brief answer. 0.94. What is the ratio of the Rating (1=low 6=high) of Macroeconomic management in 2005 to that in 2010?
Offer a terse response. 1.04. What is the ratio of the Rating (1=low 6=high) of Rule based governance in 2005 to that in 2010?
Provide a succinct answer. 0.98. What is the ratio of the Rating (1=low 6=high) of Revenue mobilization in 2005 to that in 2011?
Provide a short and direct response. 0.95. What is the ratio of the Rating (1=low 6=high) of Public resource use in 2005 to that in 2011?
Give a very brief answer. 0.93. What is the ratio of the Rating (1=low 6=high) in Macroeconomic management in 2005 to that in 2011?
Ensure brevity in your answer.  1.03. What is the ratio of the Rating (1=low 6=high) in Rule based governance in 2005 to that in 2011?
Your answer should be very brief. 0.98. What is the ratio of the Rating (1=low 6=high) of Revenue mobilization in 2005 to that in 2012?
Provide a succinct answer. 0.92. What is the ratio of the Rating (1=low 6=high) of Public resource use in 2005 to that in 2012?
Your answer should be compact. 0.93. What is the ratio of the Rating (1=low 6=high) of Macroeconomic management in 2005 to that in 2012?
Keep it short and to the point. 1.02. What is the ratio of the Rating (1=low 6=high) of Rule based governance in 2005 to that in 2012?
Make the answer very short. 0.98. What is the ratio of the Rating (1=low 6=high) of Revenue mobilization in 2006 to that in 2007?
Make the answer very short. 1.01. What is the ratio of the Rating (1=low 6=high) in Macroeconomic management in 2006 to that in 2007?
Give a very brief answer. 0.99. What is the ratio of the Rating (1=low 6=high) of Rule based governance in 2006 to that in 2007?
Ensure brevity in your answer.  0.97. What is the ratio of the Rating (1=low 6=high) of Public resource use in 2006 to that in 2008?
Ensure brevity in your answer.  0.96. What is the ratio of the Rating (1=low 6=high) of Macroeconomic management in 2006 to that in 2008?
Your response must be concise. 1.02. What is the ratio of the Rating (1=low 6=high) of Rule based governance in 2006 to that in 2008?
Your answer should be very brief. 0.97. What is the ratio of the Rating (1=low 6=high) of Revenue mobilization in 2006 to that in 2009?
Give a very brief answer. 1. What is the ratio of the Rating (1=low 6=high) of Public resource use in 2006 to that in 2009?
Provide a short and direct response. 0.95. What is the ratio of the Rating (1=low 6=high) in Macroeconomic management in 2006 to that in 2009?
Your answer should be compact. 1.07. What is the ratio of the Rating (1=low 6=high) of Rule based governance in 2006 to that in 2009?
Provide a succinct answer. 0.97. What is the ratio of the Rating (1=low 6=high) in Public resource use in 2006 to that in 2010?
Provide a succinct answer. 0.94. What is the ratio of the Rating (1=low 6=high) of Macroeconomic management in 2006 to that in 2010?
Keep it short and to the point. 1.07. What is the ratio of the Rating (1=low 6=high) in Rule based governance in 2006 to that in 2010?
Offer a very short reply. 0.97. What is the ratio of the Rating (1=low 6=high) of Revenue mobilization in 2006 to that in 2011?
Offer a terse response. 0.99. What is the ratio of the Rating (1=low 6=high) in Public resource use in 2006 to that in 2011?
Your answer should be very brief. 0.93. What is the ratio of the Rating (1=low 6=high) of Macroeconomic management in 2006 to that in 2011?
Give a very brief answer. 1.07. What is the ratio of the Rating (1=low 6=high) in Rule based governance in 2006 to that in 2011?
Your response must be concise. 0.97. What is the ratio of the Rating (1=low 6=high) of Public resource use in 2006 to that in 2012?
Your answer should be compact. 0.93. What is the ratio of the Rating (1=low 6=high) in Macroeconomic management in 2006 to that in 2012?
Give a very brief answer. 1.05. What is the ratio of the Rating (1=low 6=high) of Rule based governance in 2006 to that in 2012?
Give a very brief answer. 0.97. What is the ratio of the Rating (1=low 6=high) in Revenue mobilization in 2007 to that in 2008?
Provide a succinct answer. 0.98. What is the ratio of the Rating (1=low 6=high) in Public resource use in 2007 to that in 2008?
Provide a short and direct response. 1. What is the ratio of the Rating (1=low 6=high) of Macroeconomic management in 2007 to that in 2008?
Your response must be concise. 1.03. What is the ratio of the Rating (1=low 6=high) in Rule based governance in 2007 to that in 2008?
Make the answer very short. 1. What is the ratio of the Rating (1=low 6=high) of Revenue mobilization in 2007 to that in 2009?
Ensure brevity in your answer.  0.99. What is the ratio of the Rating (1=low 6=high) in Public resource use in 2007 to that in 2009?
Offer a terse response. 0.99. What is the ratio of the Rating (1=low 6=high) of Macroeconomic management in 2007 to that in 2009?
Offer a terse response. 1.08. What is the ratio of the Rating (1=low 6=high) in Revenue mobilization in 2007 to that in 2010?
Offer a terse response. 0.99. What is the ratio of the Rating (1=low 6=high) in Public resource use in 2007 to that in 2010?
Make the answer very short. 0.98. What is the ratio of the Rating (1=low 6=high) in Macroeconomic management in 2007 to that in 2010?
Provide a succinct answer. 1.08. What is the ratio of the Rating (1=low 6=high) in Rule based governance in 2007 to that in 2010?
Your answer should be very brief. 1. What is the ratio of the Rating (1=low 6=high) of Revenue mobilization in 2007 to that in 2011?
Offer a terse response. 0.98. What is the ratio of the Rating (1=low 6=high) in Macroeconomic management in 2007 to that in 2011?
Give a very brief answer. 1.08. What is the ratio of the Rating (1=low 6=high) in Rule based governance in 2007 to that in 2011?
Provide a succinct answer. 1. What is the ratio of the Rating (1=low 6=high) of Revenue mobilization in 2007 to that in 2012?
Make the answer very short. 0.95. What is the ratio of the Rating (1=low 6=high) in Macroeconomic management in 2007 to that in 2012?
Keep it short and to the point. 1.06. What is the ratio of the Rating (1=low 6=high) of Macroeconomic management in 2008 to that in 2009?
Ensure brevity in your answer.  1.05. What is the ratio of the Rating (1=low 6=high) of Revenue mobilization in 2008 to that in 2010?
Your answer should be very brief. 1. What is the ratio of the Rating (1=low 6=high) in Public resource use in 2008 to that in 2010?
Your answer should be compact. 0.98. What is the ratio of the Rating (1=low 6=high) of Macroeconomic management in 2008 to that in 2010?
Your answer should be compact. 1.05. What is the ratio of the Rating (1=low 6=high) in Public resource use in 2008 to that in 2011?
Give a very brief answer. 0.97. What is the ratio of the Rating (1=low 6=high) in Macroeconomic management in 2008 to that in 2011?
Your response must be concise. 1.05. What is the ratio of the Rating (1=low 6=high) in Rule based governance in 2008 to that in 2011?
Provide a succinct answer. 1. What is the ratio of the Rating (1=low 6=high) in Revenue mobilization in 2008 to that in 2012?
Make the answer very short. 0.97. What is the ratio of the Rating (1=low 6=high) of Public resource use in 2008 to that in 2012?
Keep it short and to the point. 0.97. What is the ratio of the Rating (1=low 6=high) in Macroeconomic management in 2008 to that in 2012?
Make the answer very short. 1.03. What is the ratio of the Rating (1=low 6=high) in Public resource use in 2009 to that in 2010?
Provide a succinct answer. 0.99. What is the ratio of the Rating (1=low 6=high) in Revenue mobilization in 2009 to that in 2011?
Give a very brief answer. 1. What is the ratio of the Rating (1=low 6=high) in Public resource use in 2009 to that in 2011?
Offer a very short reply. 0.97. What is the ratio of the Rating (1=low 6=high) in Macroeconomic management in 2009 to that in 2011?
Provide a short and direct response. 1. What is the ratio of the Rating (1=low 6=high) of Rule based governance in 2009 to that in 2011?
Your response must be concise. 1. What is the ratio of the Rating (1=low 6=high) of Public resource use in 2009 to that in 2012?
Your answer should be very brief. 0.97. What is the ratio of the Rating (1=low 6=high) of Macroeconomic management in 2009 to that in 2012?
Give a very brief answer. 0.98. What is the ratio of the Rating (1=low 6=high) of Revenue mobilization in 2010 to that in 2011?
Make the answer very short. 1. What is the ratio of the Rating (1=low 6=high) in Macroeconomic management in 2010 to that in 2011?
Make the answer very short. 1. What is the ratio of the Rating (1=low 6=high) in Revenue mobilization in 2010 to that in 2012?
Give a very brief answer. 0.96. What is the ratio of the Rating (1=low 6=high) of Public resource use in 2010 to that in 2012?
Provide a succinct answer. 0.99. What is the ratio of the Rating (1=low 6=high) of Macroeconomic management in 2010 to that in 2012?
Provide a short and direct response. 0.98. What is the ratio of the Rating (1=low 6=high) of Revenue mobilization in 2011 to that in 2012?
Your answer should be very brief. 0.97. What is the ratio of the Rating (1=low 6=high) in Public resource use in 2011 to that in 2012?
Provide a succinct answer. 1. What is the ratio of the Rating (1=low 6=high) in Macroeconomic management in 2011 to that in 2012?
Offer a very short reply. 0.98. What is the difference between the highest and the second highest Rating (1=low 6=high) in Revenue mobilization?
Provide a short and direct response. 0.12. What is the difference between the highest and the second highest Rating (1=low 6=high) of Public resource use?
Give a very brief answer. 0. What is the difference between the highest and the second highest Rating (1=low 6=high) of Macroeconomic management?
Provide a succinct answer. 0.03. What is the difference between the highest and the second highest Rating (1=low 6=high) in Rule based governance?
Your answer should be very brief. 0. What is the difference between the highest and the lowest Rating (1=low 6=high) of Revenue mobilization?
Offer a very short reply. 0.3. What is the difference between the highest and the lowest Rating (1=low 6=high) of Public resource use?
Your response must be concise. 0.28. What is the difference between the highest and the lowest Rating (1=low 6=high) of Macroeconomic management?
Ensure brevity in your answer.  0.32. 